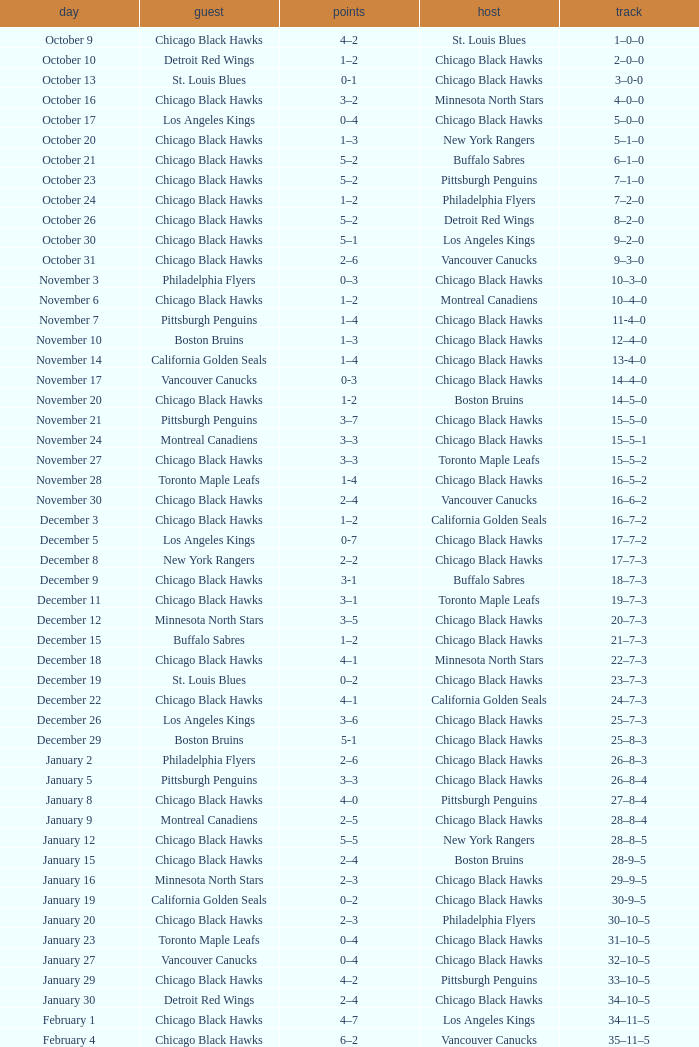What is the document of the february 26 date? 39–16–7. 